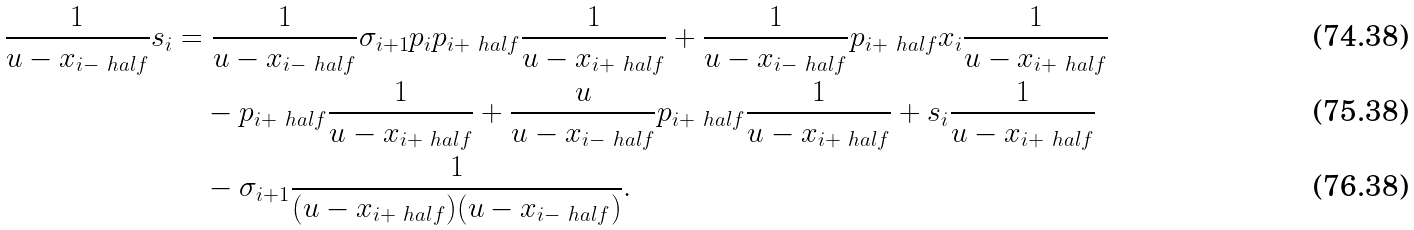<formula> <loc_0><loc_0><loc_500><loc_500>\frac { 1 } { u - x _ { i - \ h a l f } } s _ { i } & = \frac { 1 } { u - x _ { i - \ h a l f } } \sigma _ { i + 1 } p _ { i } p _ { i + \ h a l f } \frac { 1 } { u - x _ { i + \ h a l f } } + \frac { 1 } { u - x _ { i - \ h a l f } } p _ { i + \ h a l f } x _ { i } \frac { 1 } { u - x _ { i + \ h a l f } } \\ & \quad - p _ { i + \ h a l f } \frac { 1 } { u - x _ { i + \ h a l f } } + \frac { u } { u - x _ { i - \ h a l f } } p _ { i + \ h a l f } \frac { 1 } { u - x _ { i + \ h a l f } } + s _ { i } \frac { 1 } { u - x _ { i + \ h a l f } } \\ & \quad - \sigma _ { i + 1 } \frac { 1 } { ( u - x _ { i + \ h a l f } ) ( u - x _ { i - \ h a l f } ) } .</formula> 